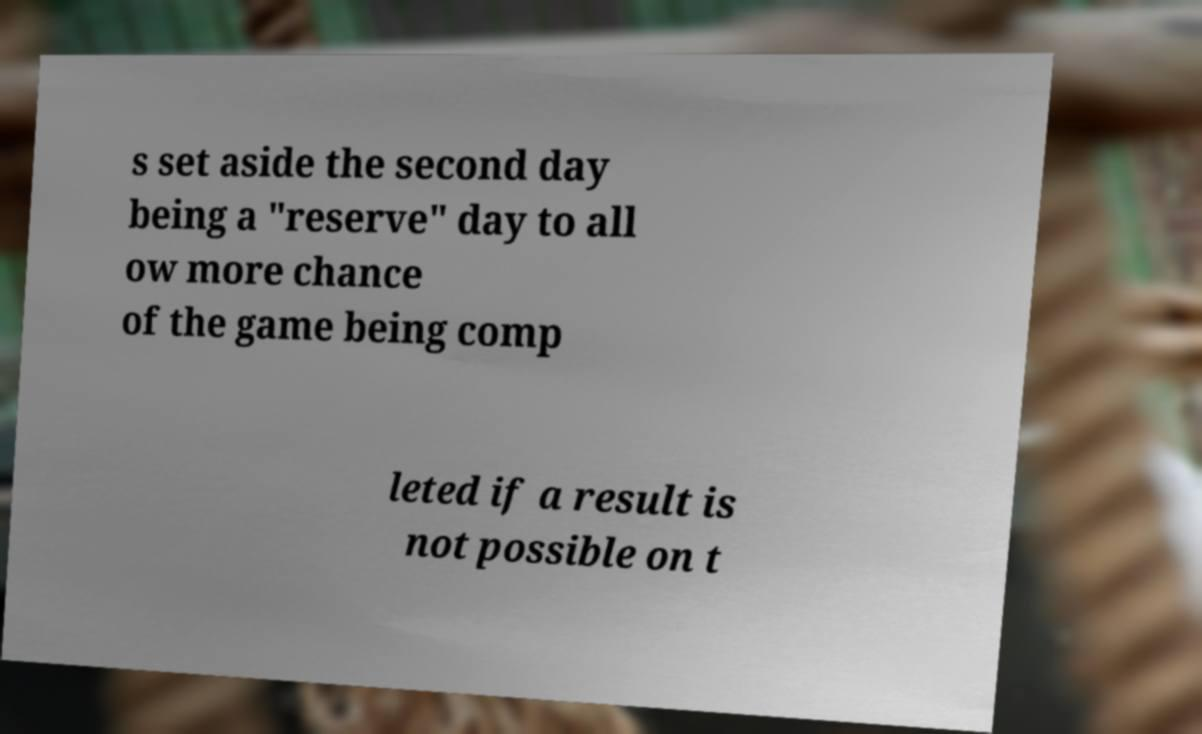There's text embedded in this image that I need extracted. Can you transcribe it verbatim? s set aside the second day being a "reserve" day to all ow more chance of the game being comp leted if a result is not possible on t 